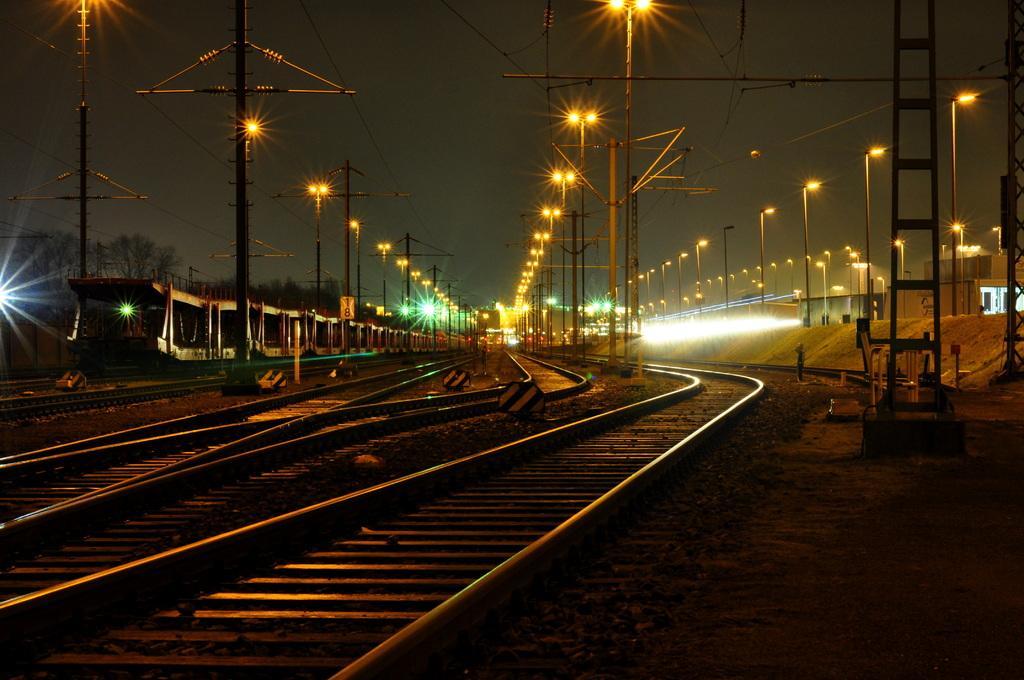Describe this image in one or two sentences. In the picture I can see few railway tracks and there is a fence wall and a train in the left corner and there are few street lights in the background. 